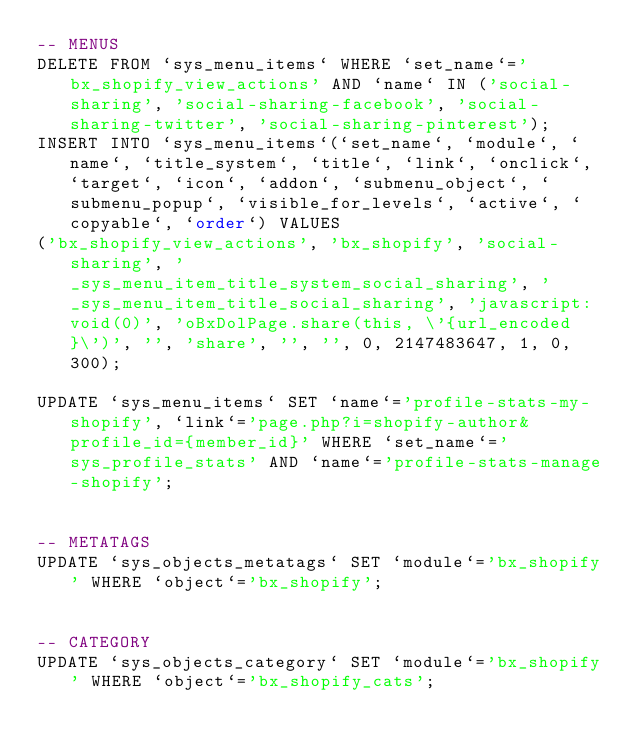<code> <loc_0><loc_0><loc_500><loc_500><_SQL_>-- MENUS
DELETE FROM `sys_menu_items` WHERE `set_name`='bx_shopify_view_actions' AND `name` IN ('social-sharing', 'social-sharing-facebook', 'social-sharing-twitter', 'social-sharing-pinterest');
INSERT INTO `sys_menu_items`(`set_name`, `module`, `name`, `title_system`, `title`, `link`, `onclick`, `target`, `icon`, `addon`, `submenu_object`, `submenu_popup`, `visible_for_levels`, `active`, `copyable`, `order`) VALUES 
('bx_shopify_view_actions', 'bx_shopify', 'social-sharing', '_sys_menu_item_title_system_social_sharing', '_sys_menu_item_title_social_sharing', 'javascript:void(0)', 'oBxDolPage.share(this, \'{url_encoded}\')', '', 'share', '', '', 0, 2147483647, 1, 0, 300);

UPDATE `sys_menu_items` SET `name`='profile-stats-my-shopify', `link`='page.php?i=shopify-author&profile_id={member_id}' WHERE `set_name`='sys_profile_stats' AND `name`='profile-stats-manage-shopify';


-- METATAGS
UPDATE `sys_objects_metatags` SET `module`='bx_shopify' WHERE `object`='bx_shopify';


-- CATEGORY
UPDATE `sys_objects_category` SET `module`='bx_shopify' WHERE `object`='bx_shopify_cats';
</code> 